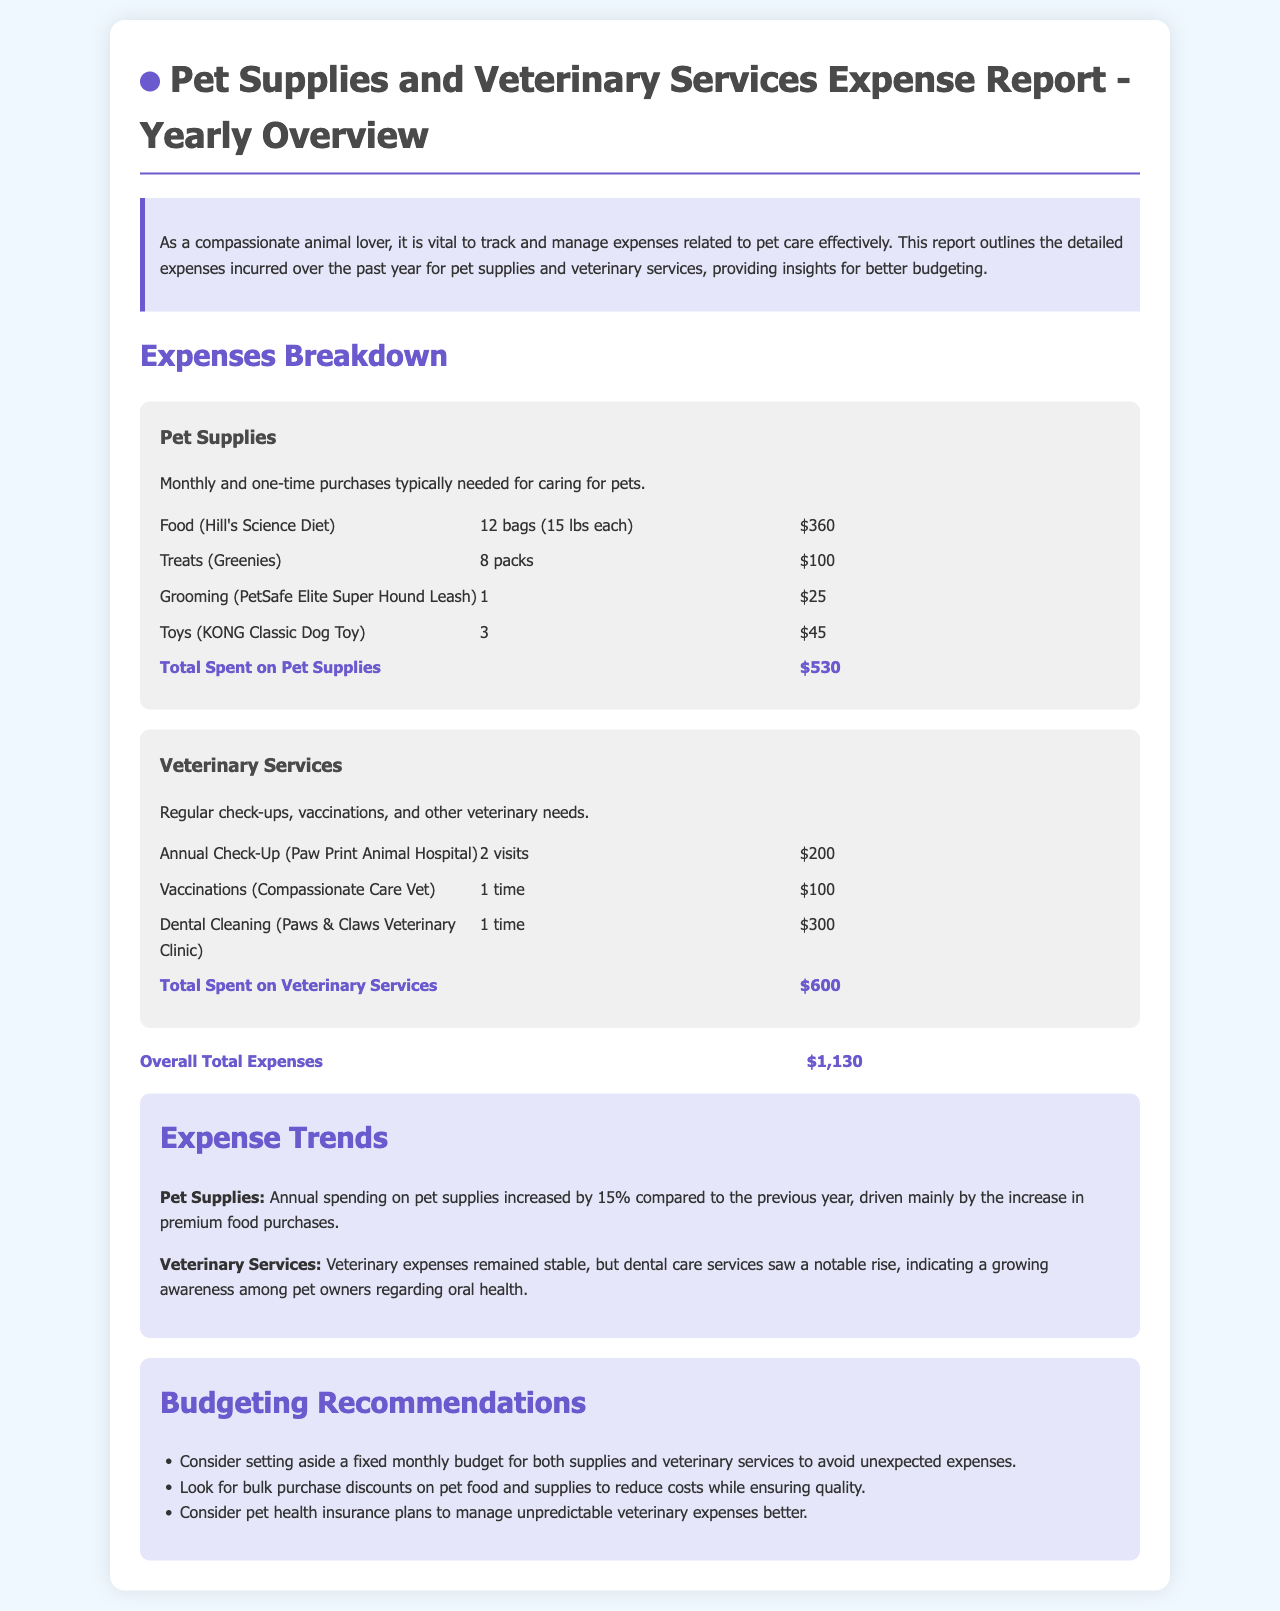What is the total spent on pet supplies? The total spent on pet supplies is clearly stated in the document under the Pet Supplies section, which lists individual expenses totaling $530.
Answer: $530 What is the total spent on veterinary services? The total spent on veterinary services is presented in the Veterinary Services section of the document, where it sums up to $600.
Answer: $600 What is the overall total expenses? The overall total expenses combine both pet supplies and veterinary services, which is given as $1,130 in the document.
Answer: $1,130 How much has the pet supplies expenditure increased compared to the previous year? The document mentions that annual spending on pet supplies increased by 15% compared to the previous year.
Answer: 15% What specific item contributed to the increase in pet supplies spending? It is stated that the increase in premium food purchases was the main cause of the increase in pet supplies costs.
Answer: Premium food purchases How many veterinary check-ups were conducted? The number of annual check-ups is provided in the Veterinary Services section, listing 2 visits for check-ups.
Answer: 2 visits What is one recommendation for managing veterinary expenses? The document offers several budgeting recommendations, one being to consider pet health insurance plans for unpredictable veterinary expenses.
Answer: Pet health insurance plans What was the cost of dental cleaning? The document states that the cost of dental cleaning at the Paws & Claws Veterinary Clinic was $300.
Answer: $300 How many packs of treats were purchased? The expense item for treats shows that 8 packs of Greenies were purchased as part of pet supplies.
Answer: 8 packs 